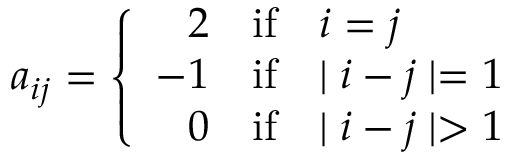<formula> <loc_0><loc_0><loc_500><loc_500>a _ { i j } = \left \{ \begin{array} { r l l } { 2 } & { i f } & { i = j } \\ { - 1 } & { i f } & { | i - j | = 1 } \\ { 0 } & { i f } & { | i - j | > 1 } \end{array}</formula> 